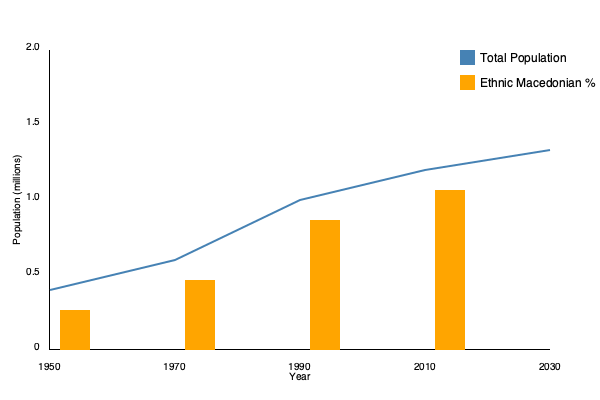Analyze the graph depicting Macedonia's population trends from 1950 to 2030. What political event in the early 1990s likely contributed to the significant change in both total population growth rate and ethnic Macedonian percentage, and how did this event impact these demographic shifts? To answer this question, we need to examine the graph and consider the historical context of Macedonia in the early 1990s:

1. Observe the total population trend (blue line):
   - From 1950 to 1990, there's a steady increase in population.
   - After 1990, the growth rate slows down significantly.

2. Analyze the ethnic Macedonian percentage (orange bars):
   - There's a notable increase in the percentage from 1990 to 2010.

3. Historical context:
   - The early 1990s marked the dissolution of Yugoslavia and Macedonia's independence in 1991.

4. Impact of independence:
   a) Slowed population growth:
      - Economic uncertainties and political transition likely led to lower birth rates.
      - Potential emigration of non-Macedonian ethnic groups.

   b) Increased ethnic Macedonian percentage:
      - Possible emigration of other ethnic groups (e.g., Serbs, Albanians) to their newly independent nations.
      - Potential immigration of ethnic Macedonians from other former Yugoslav republics.

5. Long-term effects:
   - The graph shows these trends continuing into 2030, suggesting lasting demographic changes.

The independence of Macedonia in 1991 appears to be the key political event that triggered these demographic shifts, altering both the population growth rate and ethnic composition of the country.
Answer: Macedonia's independence in 1991 